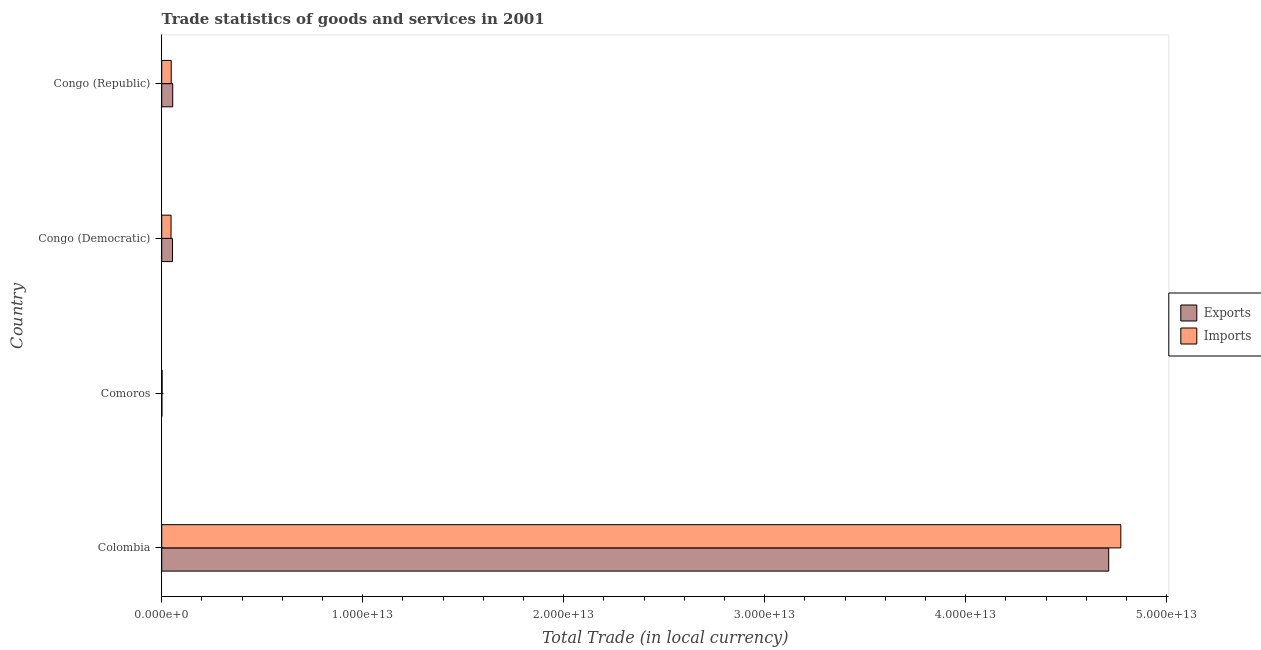Are the number of bars per tick equal to the number of legend labels?
Ensure brevity in your answer.  Yes. How many bars are there on the 1st tick from the top?
Provide a short and direct response. 2. What is the label of the 2nd group of bars from the top?
Keep it short and to the point. Congo (Democratic). In how many cases, is the number of bars for a given country not equal to the number of legend labels?
Provide a short and direct response. 0. What is the export of goods and services in Congo (Republic)?
Ensure brevity in your answer.  5.48e+11. Across all countries, what is the maximum imports of goods and services?
Keep it short and to the point. 4.77e+13. Across all countries, what is the minimum imports of goods and services?
Your answer should be compact. 2.00e+1. In which country was the export of goods and services minimum?
Make the answer very short. Comoros. What is the total imports of goods and services in the graph?
Ensure brevity in your answer.  4.87e+13. What is the difference between the imports of goods and services in Comoros and that in Congo (Democratic)?
Offer a terse response. -4.44e+11. What is the difference between the export of goods and services in Colombia and the imports of goods and services in Congo (Democratic)?
Provide a short and direct response. 4.66e+13. What is the average imports of goods and services per country?
Offer a terse response. 1.22e+13. What is the difference between the export of goods and services and imports of goods and services in Congo (Democratic)?
Give a very brief answer. 7.10e+1. What is the ratio of the export of goods and services in Colombia to that in Comoros?
Offer a very short reply. 4387.44. Is the export of goods and services in Comoros less than that in Congo (Republic)?
Ensure brevity in your answer.  Yes. Is the difference between the imports of goods and services in Comoros and Congo (Republic) greater than the difference between the export of goods and services in Comoros and Congo (Republic)?
Offer a very short reply. Yes. What is the difference between the highest and the second highest export of goods and services?
Your response must be concise. 4.66e+13. What is the difference between the highest and the lowest export of goods and services?
Keep it short and to the point. 4.71e+13. Is the sum of the export of goods and services in Comoros and Congo (Democratic) greater than the maximum imports of goods and services across all countries?
Provide a short and direct response. No. What does the 1st bar from the top in Colombia represents?
Your answer should be very brief. Imports. What does the 2nd bar from the bottom in Comoros represents?
Make the answer very short. Imports. What is the difference between two consecutive major ticks on the X-axis?
Provide a succinct answer. 1.00e+13. Are the values on the major ticks of X-axis written in scientific E-notation?
Provide a short and direct response. Yes. How many legend labels are there?
Ensure brevity in your answer.  2. How are the legend labels stacked?
Make the answer very short. Vertical. What is the title of the graph?
Provide a succinct answer. Trade statistics of goods and services in 2001. What is the label or title of the X-axis?
Ensure brevity in your answer.  Total Trade (in local currency). What is the Total Trade (in local currency) of Exports in Colombia?
Your answer should be very brief. 4.71e+13. What is the Total Trade (in local currency) of Imports in Colombia?
Ensure brevity in your answer.  4.77e+13. What is the Total Trade (in local currency) in Exports in Comoros?
Your response must be concise. 1.07e+1. What is the Total Trade (in local currency) of Imports in Comoros?
Offer a terse response. 2.00e+1. What is the Total Trade (in local currency) of Exports in Congo (Democratic)?
Provide a short and direct response. 5.35e+11. What is the Total Trade (in local currency) in Imports in Congo (Democratic)?
Give a very brief answer. 4.64e+11. What is the Total Trade (in local currency) in Exports in Congo (Republic)?
Offer a very short reply. 5.48e+11. What is the Total Trade (in local currency) of Imports in Congo (Republic)?
Offer a very short reply. 4.73e+11. Across all countries, what is the maximum Total Trade (in local currency) of Exports?
Your answer should be compact. 4.71e+13. Across all countries, what is the maximum Total Trade (in local currency) of Imports?
Give a very brief answer. 4.77e+13. Across all countries, what is the minimum Total Trade (in local currency) of Exports?
Keep it short and to the point. 1.07e+1. Across all countries, what is the minimum Total Trade (in local currency) in Imports?
Ensure brevity in your answer.  2.00e+1. What is the total Total Trade (in local currency) of Exports in the graph?
Make the answer very short. 4.82e+13. What is the total Total Trade (in local currency) of Imports in the graph?
Offer a very short reply. 4.87e+13. What is the difference between the Total Trade (in local currency) of Exports in Colombia and that in Comoros?
Offer a terse response. 4.71e+13. What is the difference between the Total Trade (in local currency) in Imports in Colombia and that in Comoros?
Your response must be concise. 4.77e+13. What is the difference between the Total Trade (in local currency) of Exports in Colombia and that in Congo (Democratic)?
Keep it short and to the point. 4.66e+13. What is the difference between the Total Trade (in local currency) in Imports in Colombia and that in Congo (Democratic)?
Make the answer very short. 4.72e+13. What is the difference between the Total Trade (in local currency) of Exports in Colombia and that in Congo (Republic)?
Your answer should be very brief. 4.66e+13. What is the difference between the Total Trade (in local currency) of Imports in Colombia and that in Congo (Republic)?
Offer a very short reply. 4.72e+13. What is the difference between the Total Trade (in local currency) of Exports in Comoros and that in Congo (Democratic)?
Keep it short and to the point. -5.24e+11. What is the difference between the Total Trade (in local currency) in Imports in Comoros and that in Congo (Democratic)?
Give a very brief answer. -4.44e+11. What is the difference between the Total Trade (in local currency) in Exports in Comoros and that in Congo (Republic)?
Make the answer very short. -5.37e+11. What is the difference between the Total Trade (in local currency) of Imports in Comoros and that in Congo (Republic)?
Make the answer very short. -4.53e+11. What is the difference between the Total Trade (in local currency) of Exports in Congo (Democratic) and that in Congo (Republic)?
Give a very brief answer. -1.30e+1. What is the difference between the Total Trade (in local currency) in Imports in Congo (Democratic) and that in Congo (Republic)?
Your response must be concise. -8.56e+09. What is the difference between the Total Trade (in local currency) of Exports in Colombia and the Total Trade (in local currency) of Imports in Comoros?
Your response must be concise. 4.71e+13. What is the difference between the Total Trade (in local currency) in Exports in Colombia and the Total Trade (in local currency) in Imports in Congo (Democratic)?
Give a very brief answer. 4.66e+13. What is the difference between the Total Trade (in local currency) of Exports in Colombia and the Total Trade (in local currency) of Imports in Congo (Republic)?
Give a very brief answer. 4.66e+13. What is the difference between the Total Trade (in local currency) in Exports in Comoros and the Total Trade (in local currency) in Imports in Congo (Democratic)?
Make the answer very short. -4.53e+11. What is the difference between the Total Trade (in local currency) of Exports in Comoros and the Total Trade (in local currency) of Imports in Congo (Republic)?
Make the answer very short. -4.62e+11. What is the difference between the Total Trade (in local currency) of Exports in Congo (Democratic) and the Total Trade (in local currency) of Imports in Congo (Republic)?
Your answer should be very brief. 6.24e+1. What is the average Total Trade (in local currency) in Exports per country?
Provide a short and direct response. 1.21e+13. What is the average Total Trade (in local currency) in Imports per country?
Keep it short and to the point. 1.22e+13. What is the difference between the Total Trade (in local currency) of Exports and Total Trade (in local currency) of Imports in Colombia?
Offer a terse response. -6.03e+11. What is the difference between the Total Trade (in local currency) of Exports and Total Trade (in local currency) of Imports in Comoros?
Give a very brief answer. -9.28e+09. What is the difference between the Total Trade (in local currency) in Exports and Total Trade (in local currency) in Imports in Congo (Democratic)?
Provide a succinct answer. 7.10e+1. What is the difference between the Total Trade (in local currency) of Exports and Total Trade (in local currency) of Imports in Congo (Republic)?
Give a very brief answer. 7.54e+1. What is the ratio of the Total Trade (in local currency) in Exports in Colombia to that in Comoros?
Offer a very short reply. 4387.44. What is the ratio of the Total Trade (in local currency) in Imports in Colombia to that in Comoros?
Provide a short and direct response. 2383.3. What is the ratio of the Total Trade (in local currency) in Exports in Colombia to that in Congo (Democratic)?
Provide a succinct answer. 88.02. What is the ratio of the Total Trade (in local currency) in Imports in Colombia to that in Congo (Democratic)?
Offer a terse response. 102.79. What is the ratio of the Total Trade (in local currency) in Exports in Colombia to that in Congo (Republic)?
Ensure brevity in your answer.  85.94. What is the ratio of the Total Trade (in local currency) in Imports in Colombia to that in Congo (Republic)?
Your answer should be very brief. 100.92. What is the ratio of the Total Trade (in local currency) of Exports in Comoros to that in Congo (Democratic)?
Give a very brief answer. 0.02. What is the ratio of the Total Trade (in local currency) in Imports in Comoros to that in Congo (Democratic)?
Give a very brief answer. 0.04. What is the ratio of the Total Trade (in local currency) of Exports in Comoros to that in Congo (Republic)?
Keep it short and to the point. 0.02. What is the ratio of the Total Trade (in local currency) of Imports in Comoros to that in Congo (Republic)?
Provide a succinct answer. 0.04. What is the ratio of the Total Trade (in local currency) in Exports in Congo (Democratic) to that in Congo (Republic)?
Make the answer very short. 0.98. What is the ratio of the Total Trade (in local currency) in Imports in Congo (Democratic) to that in Congo (Republic)?
Your answer should be very brief. 0.98. What is the difference between the highest and the second highest Total Trade (in local currency) in Exports?
Keep it short and to the point. 4.66e+13. What is the difference between the highest and the second highest Total Trade (in local currency) in Imports?
Offer a terse response. 4.72e+13. What is the difference between the highest and the lowest Total Trade (in local currency) in Exports?
Give a very brief answer. 4.71e+13. What is the difference between the highest and the lowest Total Trade (in local currency) of Imports?
Your answer should be very brief. 4.77e+13. 